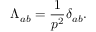Convert formula to latex. <formula><loc_0><loc_0><loc_500><loc_500>\Lambda _ { a b } = \frac { 1 } { p ^ { 2 } } \delta _ { a b } .</formula> 